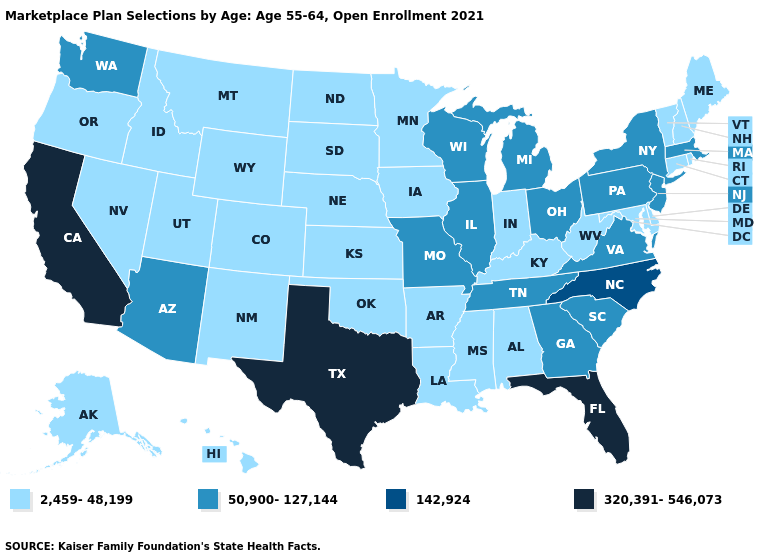Which states have the lowest value in the West?
Concise answer only. Alaska, Colorado, Hawaii, Idaho, Montana, Nevada, New Mexico, Oregon, Utah, Wyoming. What is the lowest value in states that border Washington?
Short answer required. 2,459-48,199. Name the states that have a value in the range 142,924?
Short answer required. North Carolina. Is the legend a continuous bar?
Give a very brief answer. No. Name the states that have a value in the range 2,459-48,199?
Write a very short answer. Alabama, Alaska, Arkansas, Colorado, Connecticut, Delaware, Hawaii, Idaho, Indiana, Iowa, Kansas, Kentucky, Louisiana, Maine, Maryland, Minnesota, Mississippi, Montana, Nebraska, Nevada, New Hampshire, New Mexico, North Dakota, Oklahoma, Oregon, Rhode Island, South Dakota, Utah, Vermont, West Virginia, Wyoming. Does the map have missing data?
Answer briefly. No. Among the states that border Mississippi , does Tennessee have the lowest value?
Short answer required. No. Among the states that border Montana , which have the lowest value?
Quick response, please. Idaho, North Dakota, South Dakota, Wyoming. Name the states that have a value in the range 2,459-48,199?
Give a very brief answer. Alabama, Alaska, Arkansas, Colorado, Connecticut, Delaware, Hawaii, Idaho, Indiana, Iowa, Kansas, Kentucky, Louisiana, Maine, Maryland, Minnesota, Mississippi, Montana, Nebraska, Nevada, New Hampshire, New Mexico, North Dakota, Oklahoma, Oregon, Rhode Island, South Dakota, Utah, Vermont, West Virginia, Wyoming. What is the lowest value in the South?
Keep it brief. 2,459-48,199. Which states have the lowest value in the West?
Give a very brief answer. Alaska, Colorado, Hawaii, Idaho, Montana, Nevada, New Mexico, Oregon, Utah, Wyoming. Name the states that have a value in the range 320,391-546,073?
Write a very short answer. California, Florida, Texas. Among the states that border Kansas , does Missouri have the highest value?
Give a very brief answer. Yes. What is the value of Hawaii?
Write a very short answer. 2,459-48,199. What is the lowest value in the South?
Quick response, please. 2,459-48,199. 